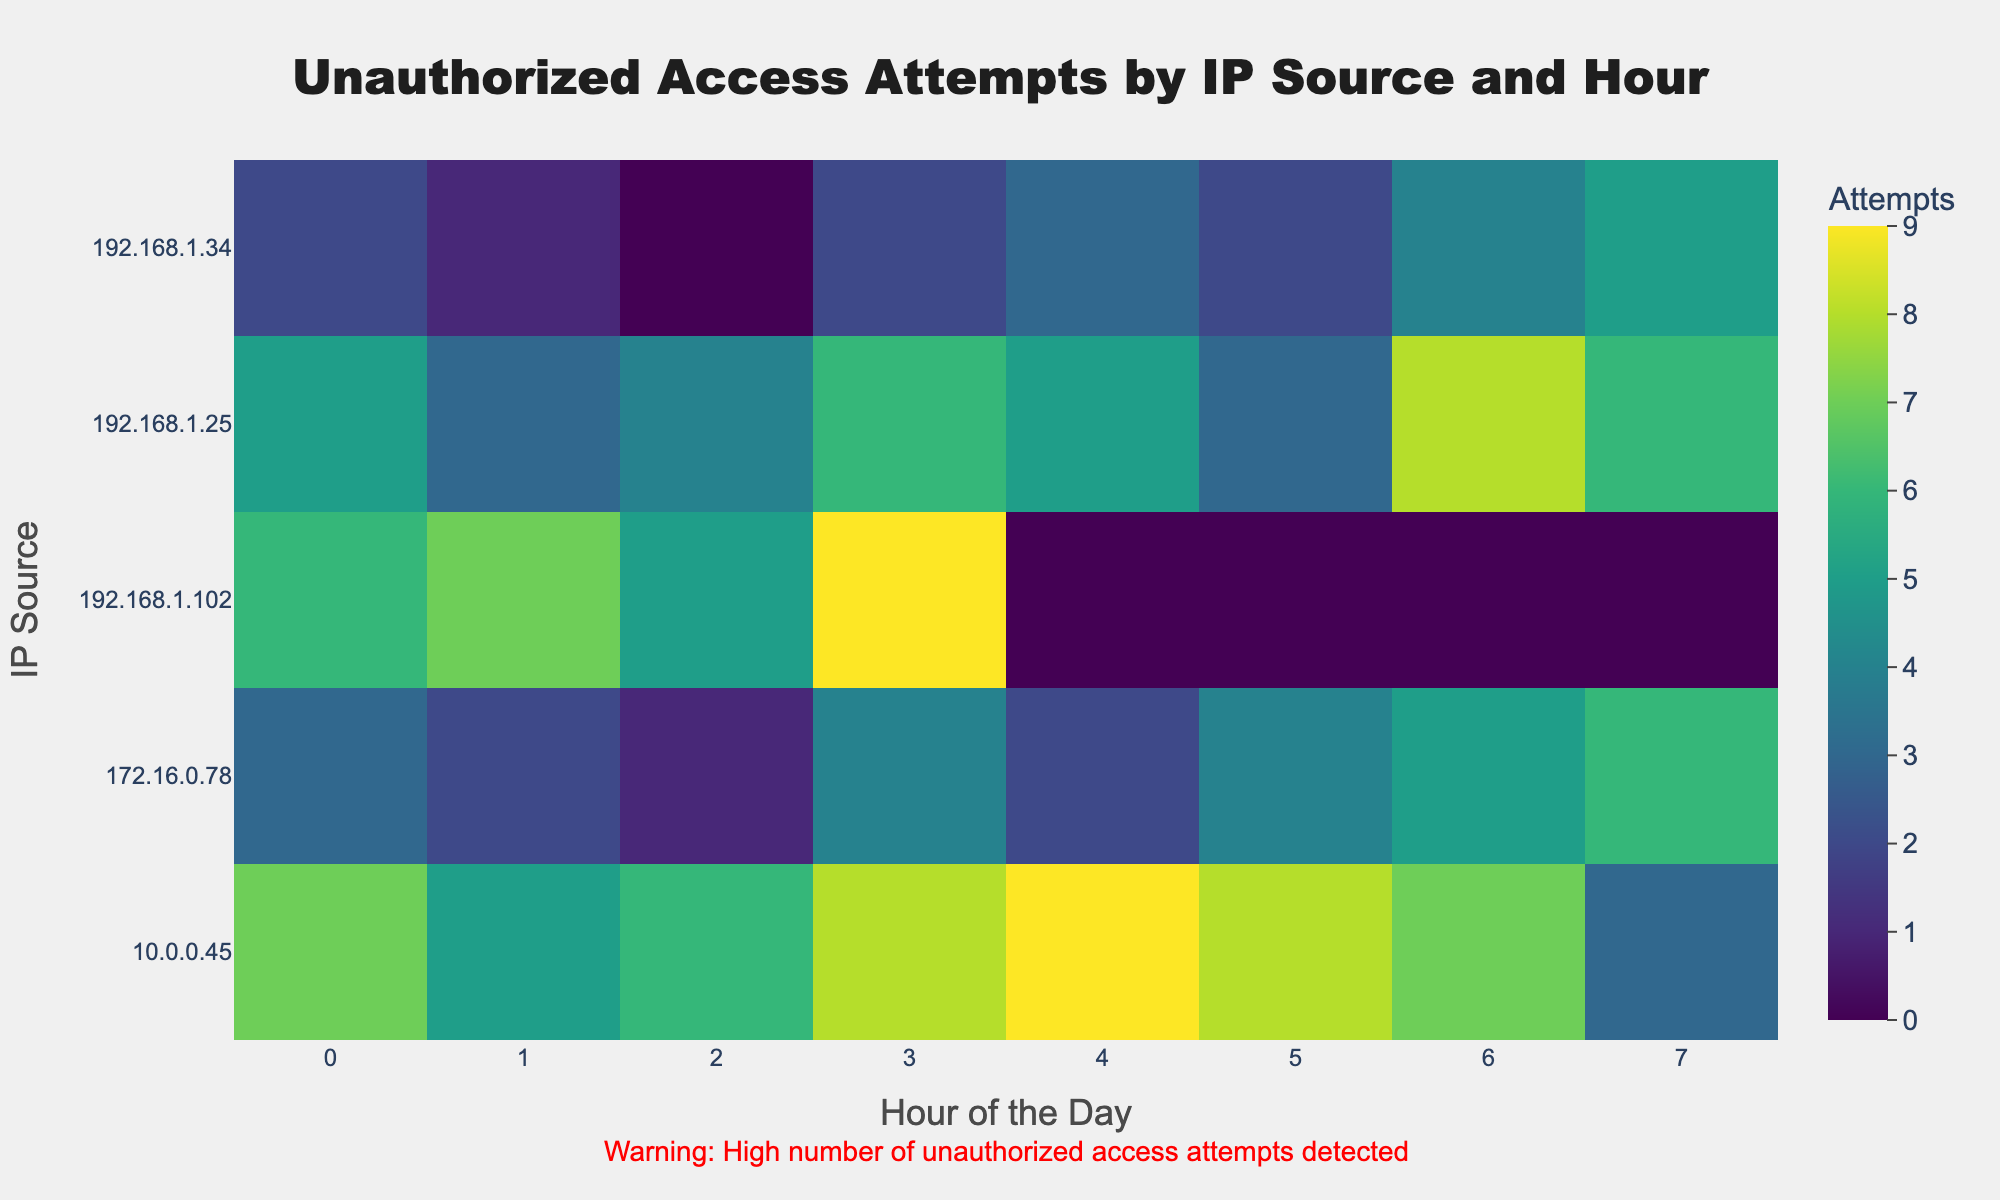What is the title of the heatmap? The title is usually placed at the top of the heatmap. In this case, it says "Unauthorized Access Attempts by IP Source and Hour".
Answer: Unauthorized Access Attempts by IP Source and Hour Which hour and IP had the highest number of unauthorized access attempts? Look for the cell with the highest value. Here, it is the cell where Hour is 3 and IP is 192.168.1.102 with 9 attempts.
Answer: Hour 3 and IP 192.168.1.102 Which IP address has the most consistent number of unauthorized access attempts across different hours? Consistency can be observed where values are more evenly spread out without too much variation. The IP 10.0.0.45 has values close to each other across the hours.
Answer: 10.0.0.45 What is the total number of unauthorized access attempts from 192.168.1.25? Sum all the values of the attempts for IP address 192.168.1.25 across all the hours. (5+3+4+6+5+3+8+6)
Answer: 40 Which hour showed the highest total number of unauthorized access attempts across all IPs? Sum the values of attempts for each column (hour) and identify the highest sum. Here, Hour 3 (6+2+8+4+9) has the highest total.
Answer: Hour 3 Which IP address has the least total number of unauthorized access attempts? Sum the values of the attempts for each IP across all hours, and identify the smallest sum. Here, IP 172.16.0.78 (3+2+1+4+2+4+5+6) has the least total.
Answer: 172.16.0.78 What is the range of unauthorized access attempts for the IP 192.168.1.34 between hours 4 and 7? Determine the minimum and maximum values of attempts for IP 192.168.1.34 during hours 4 to 7, and then find the range (difference between max and min). For 192.168.1.34, values are 3, 2, 4, 5; range is 5-2.
Answer: 3 How many IP addresses experienced more than 7 unauthorized access attempts in any given hour? Check each IP and count how many have more than 7 attempts in at least one hour. Here, 192.168.1.102, 10.0.0.45, and 192.168.1.25 have such instances.
Answer: 3 Which IP address had a sudden increase in the number of unauthorized access attempts between any two consecutive hours? Compare the number of attempts between consecutive hours for each IP and find the largest positive difference. For 192.168.1.102, attempts go from 7 at hour 1 to 9 at hour 3, which is an increase of 2, but 192.168.1.25 goes from 3 at hour 5 to 8 at hour 6, which is an increase of 5.
Answer: 192.168.1.25 What is the average number of unauthorized access attempts per hour for the IP 10.0.0.45? Sum the total number of attempts for IP 10.0.0.45 and divide by the number of hours recorded. Total attempts are 55; hours are 0 through 7, which are 8 hours.
Answer: 6.875 